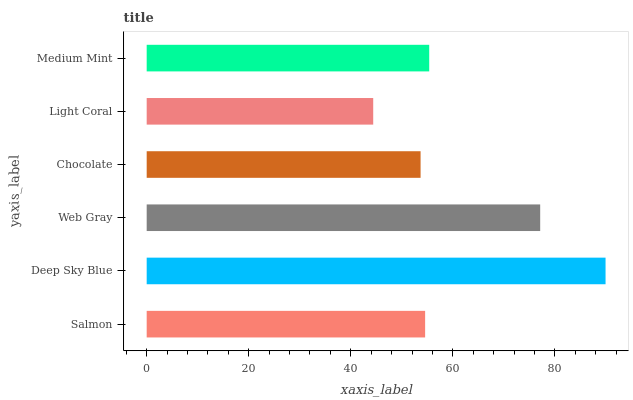Is Light Coral the minimum?
Answer yes or no. Yes. Is Deep Sky Blue the maximum?
Answer yes or no. Yes. Is Web Gray the minimum?
Answer yes or no. No. Is Web Gray the maximum?
Answer yes or no. No. Is Deep Sky Blue greater than Web Gray?
Answer yes or no. Yes. Is Web Gray less than Deep Sky Blue?
Answer yes or no. Yes. Is Web Gray greater than Deep Sky Blue?
Answer yes or no. No. Is Deep Sky Blue less than Web Gray?
Answer yes or no. No. Is Medium Mint the high median?
Answer yes or no. Yes. Is Salmon the low median?
Answer yes or no. Yes. Is Salmon the high median?
Answer yes or no. No. Is Deep Sky Blue the low median?
Answer yes or no. No. 